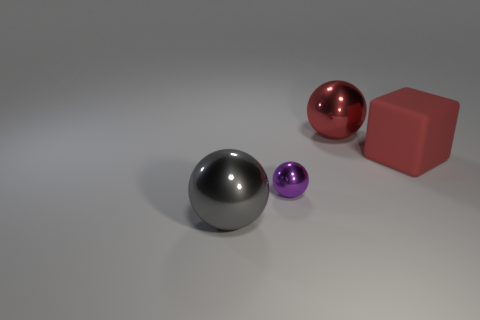The sphere that is the same color as the matte block is what size?
Give a very brief answer. Large. What material is the sphere that is the same color as the big rubber cube?
Your response must be concise. Metal. Is there any other thing that is the same size as the purple shiny sphere?
Your answer should be very brief. No. Is the number of gray objects that are to the right of the purple sphere less than the number of metallic spheres that are on the left side of the red sphere?
Your answer should be very brief. Yes. What number of other things are made of the same material as the purple sphere?
Your answer should be compact. 2. There is a red sphere that is the same size as the gray metallic sphere; what is its material?
Provide a short and direct response. Metal. Are there fewer small purple objects on the left side of the purple thing than tiny gray blocks?
Provide a short and direct response. No. What shape is the shiny thing that is behind the big red thing that is to the right of the large metal ball that is on the right side of the small sphere?
Your response must be concise. Sphere. There is a purple thing in front of the big red shiny object; what size is it?
Make the answer very short. Small. There is a red thing that is the same size as the red shiny sphere; what is its shape?
Your response must be concise. Cube. 